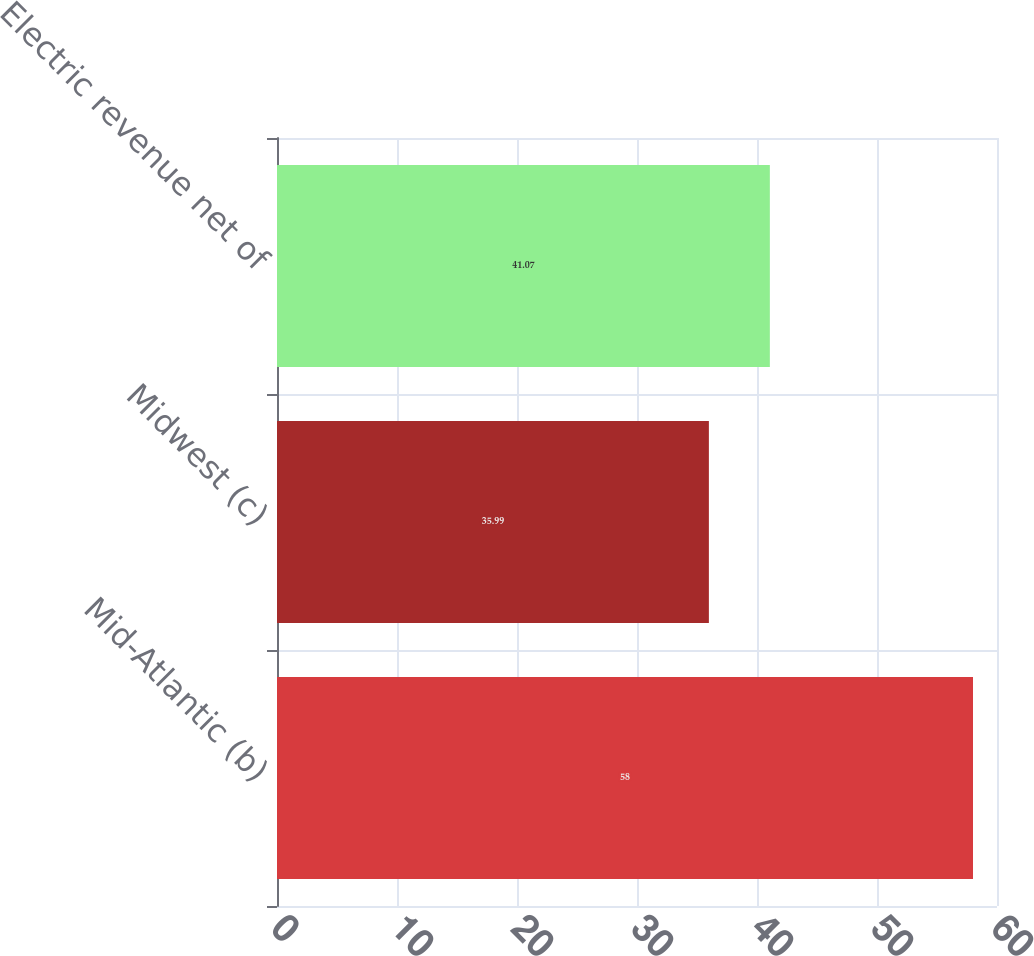Convert chart. <chart><loc_0><loc_0><loc_500><loc_500><bar_chart><fcel>Mid-Atlantic (b)<fcel>Midwest (c)<fcel>Electric revenue net of<nl><fcel>58<fcel>35.99<fcel>41.07<nl></chart> 